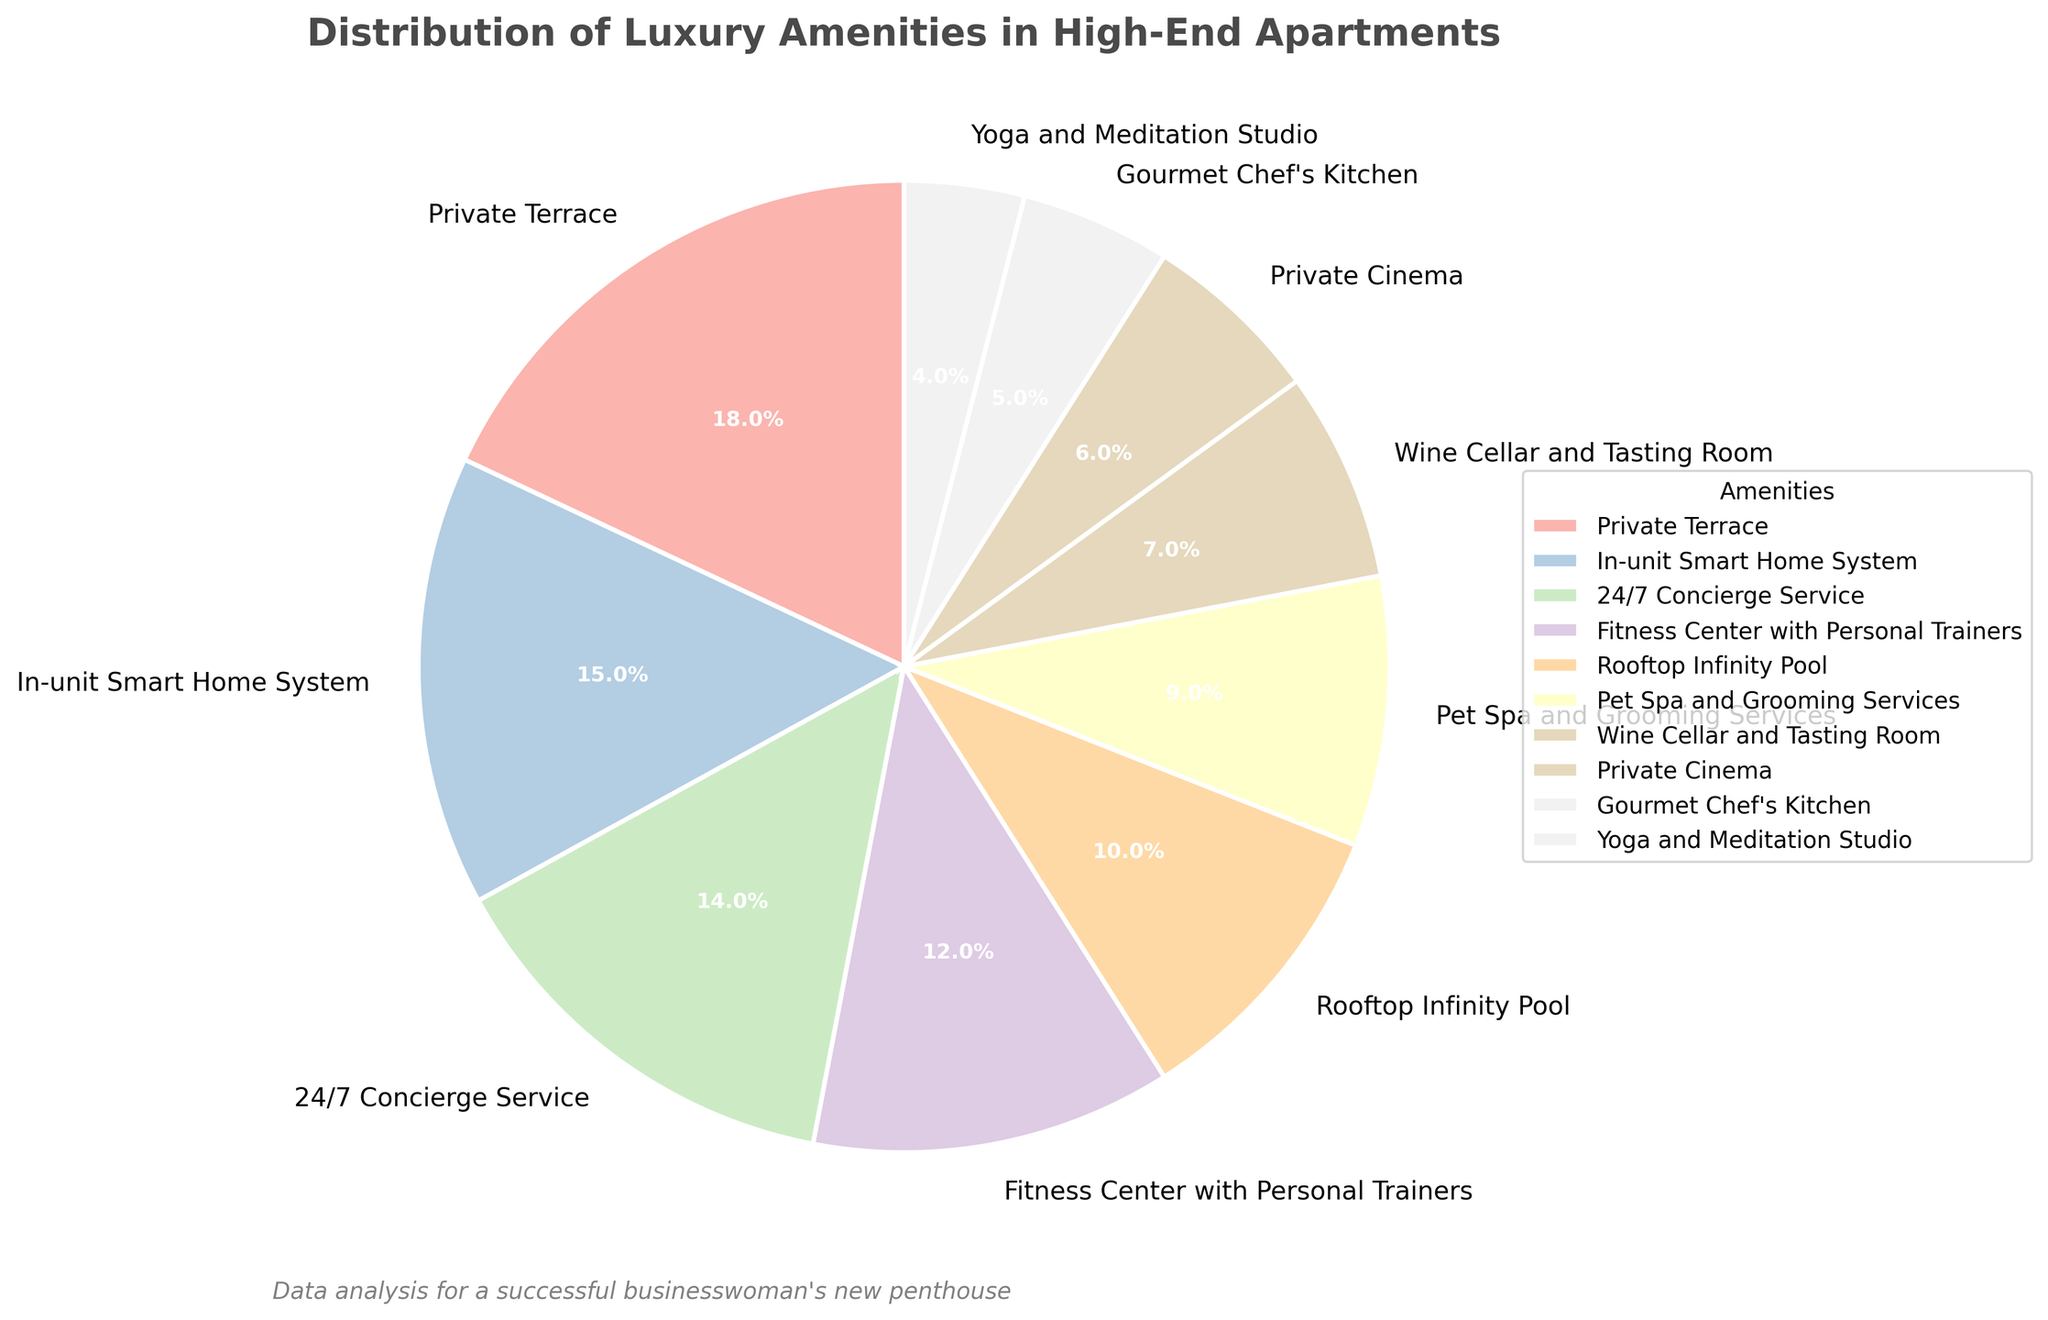Which amenity has the highest percentage share? The pie chart shows the percentages of various amenities, and the slice with the largest percentage represents the amenity with the highest share. The "Private Terrace" has the largest percentage at 18%.
Answer: Private Terrace What is the combined percentage of amenities related to health and fitness? To find the combined percentage, sum the percentages of the relevant amenities: "Fitness Center with Personal Trainers" at 12%, "Yoga and Meditation Studio" at 4%, which equals 12% + 4% = 16%.
Answer: 16% How does the percentage of "Pet Spa and Grooming Services" compare to that of the "Wine Cellar and Tasting Room"? The percentage of "Pet Spa and Grooming Services" is 9%, while the "Wine Cellar and Tasting Room" is at 7%. Since 9% is greater than 7%, "Pet Spa and Grooming Services" has a higher percentage.
Answer: Pet Spa and Grooming Services What is the total percentage for amenities that cater to leisure activities? Leisure activities can be categorized as "Private Cinema" at 6% and "Wine Cellar and Tasting Room" at 7%. Summing these gives 6% + 7% = 13%.
Answer: 13% Which amenity has the smallest percentage share, and what is it? By looking at the pie chart, the smallest slice represents the lowest percentage. The "Yoga and Meditation Studio" has the smallest share at 4%.
Answer: Yoga and Meditation Studio How much more popular is the "In-unit Smart Home System" compared to the "Gourmet Chef's Kitchen"? Subtract the percentage of the "Gourmet Chef's Kitchen" (5%) from the "In-unit Smart Home System" (15%). This gives 15% - 5% = 10%.
Answer: 10% What is the visual difference between the slice representing the "Rooftop Infinity Pool" and the "24/7 Concierge Service"? The slice for the "Rooftop Infinity Pool" accounts for 10%, whereas "24/7 Concierge Service" is at 14%. Visually, the "24/7 Concierge Service" slice is larger.
Answer: "24/7 Concierge Service" is larger If the "Private Terrace" and "In-unit Smart Home System" were combined into one amenity, what percentage would it represent? Adding the percentages of the "Private Terrace" (18%) and the "In-unit Smart Home System" (15%) gives 18% + 15% = 33%.
Answer: 33% What percentage of the pie chart is occupied by amenities catering specifically to pets? The "Pet Spa and Grooming Services" is the only amenity specifically catering to pets, representing 9%.
Answer: 9% 